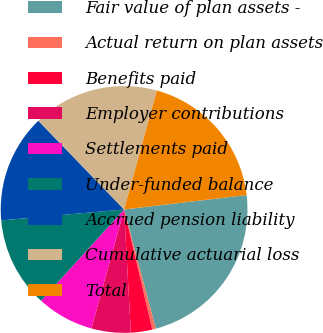Convert chart. <chart><loc_0><loc_0><loc_500><loc_500><pie_chart><fcel>Fair value of plan assets -<fcel>Actual return on plan assets<fcel>Benefits paid<fcel>Employer contributions<fcel>Settlements paid<fcel>Under-funded balance<fcel>Accrued pension liability<fcel>Cumulative actuarial loss<fcel>Total<nl><fcel>22.73%<fcel>0.46%<fcel>2.8%<fcel>5.14%<fcel>7.48%<fcel>11.84%<fcel>14.18%<fcel>16.52%<fcel>18.86%<nl></chart> 